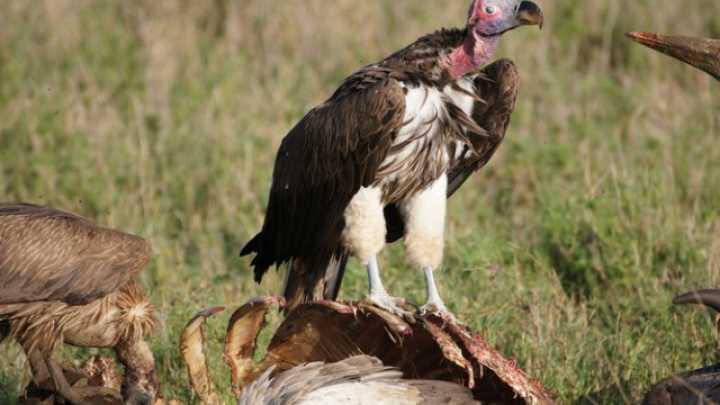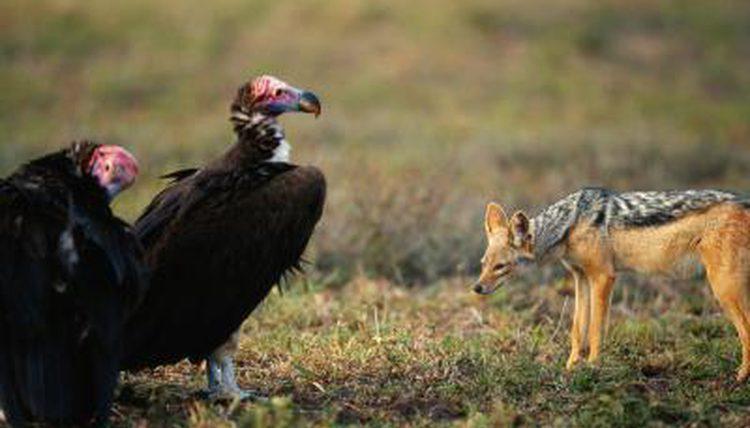The first image is the image on the left, the second image is the image on the right. Evaluate the accuracy of this statement regarding the images: "A vulture has its wings spread, as it confronts another vulture". Is it true? Answer yes or no. No. The first image is the image on the left, the second image is the image on the right. For the images displayed, is the sentence "The left image shows one foreground vulture, which stands on a carcass with its head facing right." factually correct? Answer yes or no. Yes. 